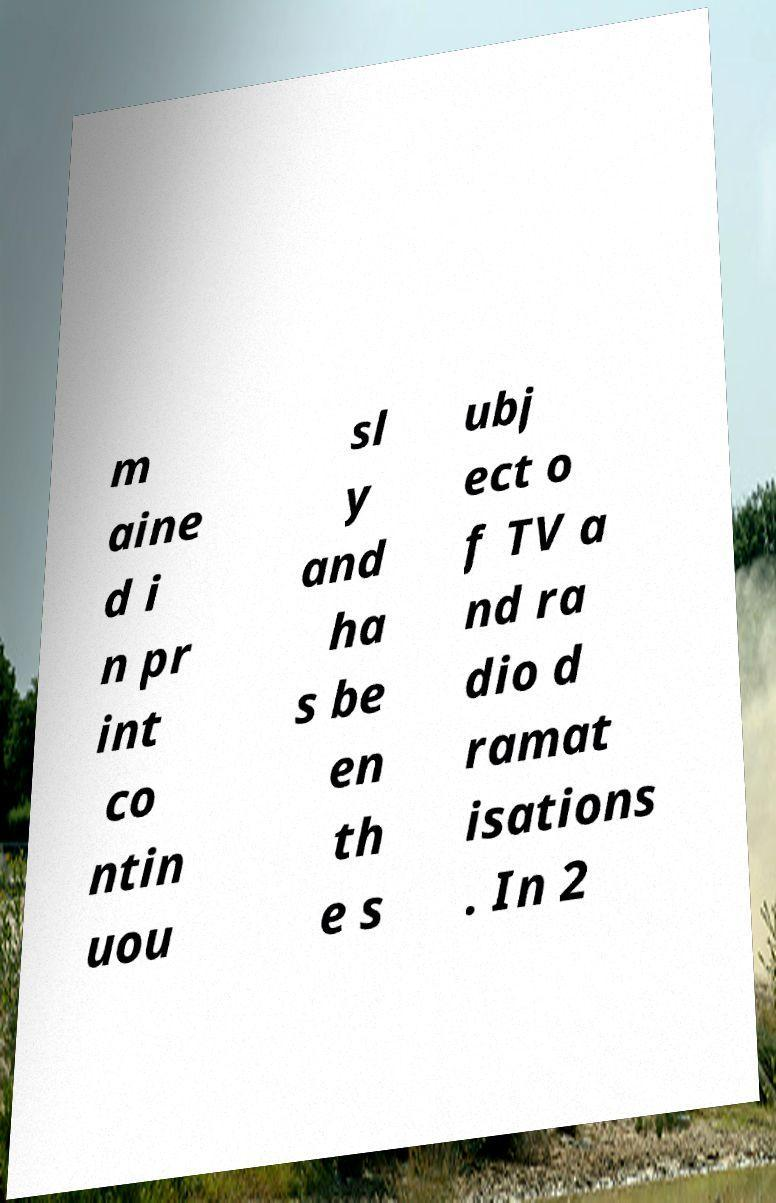For documentation purposes, I need the text within this image transcribed. Could you provide that? m aine d i n pr int co ntin uou sl y and ha s be en th e s ubj ect o f TV a nd ra dio d ramat isations . In 2 